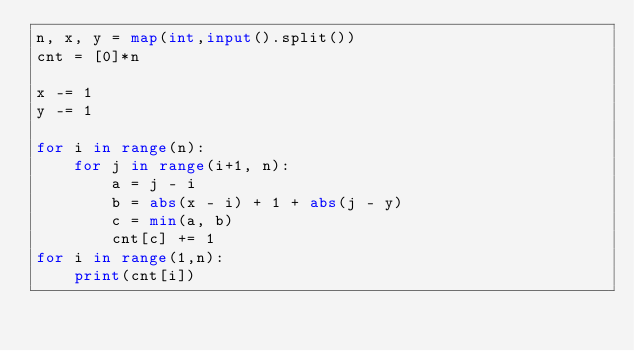<code> <loc_0><loc_0><loc_500><loc_500><_Python_>n, x, y = map(int,input().split())
cnt = [0]*n

x -= 1
y -= 1

for i in range(n):
    for j in range(i+1, n):
        a = j - i
        b = abs(x - i) + 1 + abs(j - y)
        c = min(a, b)
        cnt[c] += 1
for i in range(1,n):
    print(cnt[i])
</code> 